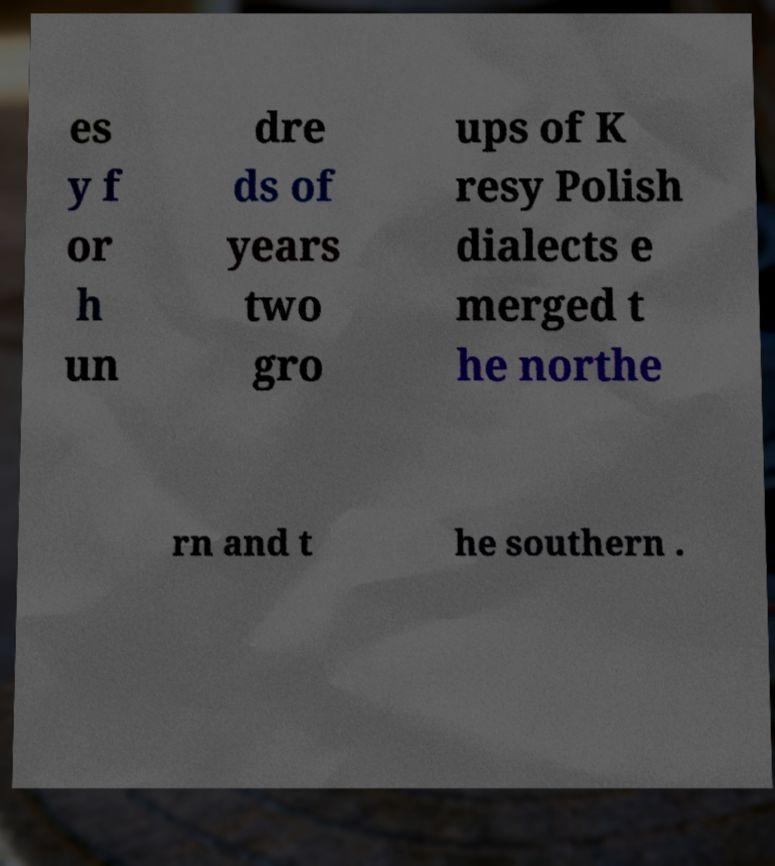Could you assist in decoding the text presented in this image and type it out clearly? es y f or h un dre ds of years two gro ups of K resy Polish dialects e merged t he northe rn and t he southern . 